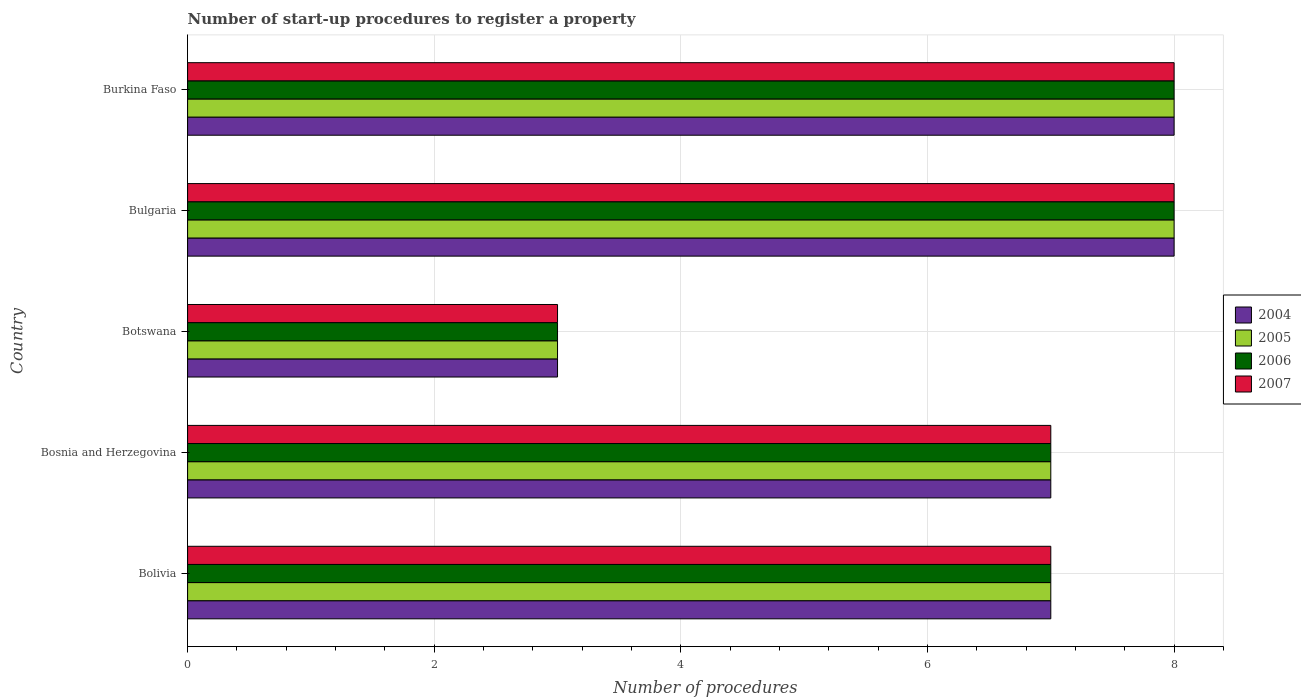How many different coloured bars are there?
Offer a very short reply. 4. How many groups of bars are there?
Keep it short and to the point. 5. Are the number of bars per tick equal to the number of legend labels?
Keep it short and to the point. Yes. Are the number of bars on each tick of the Y-axis equal?
Offer a very short reply. Yes. Across all countries, what is the maximum number of procedures required to register a property in 2007?
Keep it short and to the point. 8. Across all countries, what is the minimum number of procedures required to register a property in 2007?
Make the answer very short. 3. In which country was the number of procedures required to register a property in 2007 maximum?
Make the answer very short. Bulgaria. In which country was the number of procedures required to register a property in 2006 minimum?
Your response must be concise. Botswana. What is the total number of procedures required to register a property in 2007 in the graph?
Offer a very short reply. 33. Is the number of procedures required to register a property in 2006 in Bosnia and Herzegovina less than that in Bulgaria?
Provide a succinct answer. Yes. Is the difference between the number of procedures required to register a property in 2006 in Bolivia and Burkina Faso greater than the difference between the number of procedures required to register a property in 2007 in Bolivia and Burkina Faso?
Provide a succinct answer. No. What is the difference between the highest and the second highest number of procedures required to register a property in 2004?
Provide a short and direct response. 0. What is the difference between the highest and the lowest number of procedures required to register a property in 2005?
Provide a succinct answer. 5. In how many countries, is the number of procedures required to register a property in 2006 greater than the average number of procedures required to register a property in 2006 taken over all countries?
Your answer should be compact. 4. Is the sum of the number of procedures required to register a property in 2005 in Botswana and Bulgaria greater than the maximum number of procedures required to register a property in 2006 across all countries?
Ensure brevity in your answer.  Yes. What does the 3rd bar from the top in Botswana represents?
Give a very brief answer. 2005. How many bars are there?
Your response must be concise. 20. Are all the bars in the graph horizontal?
Offer a terse response. Yes. How many countries are there in the graph?
Provide a short and direct response. 5. What is the difference between two consecutive major ticks on the X-axis?
Make the answer very short. 2. Does the graph contain any zero values?
Keep it short and to the point. No. Does the graph contain grids?
Your answer should be compact. Yes. Where does the legend appear in the graph?
Your answer should be very brief. Center right. How are the legend labels stacked?
Give a very brief answer. Vertical. What is the title of the graph?
Make the answer very short. Number of start-up procedures to register a property. What is the label or title of the X-axis?
Make the answer very short. Number of procedures. What is the label or title of the Y-axis?
Your answer should be compact. Country. What is the Number of procedures of 2005 in Bolivia?
Keep it short and to the point. 7. What is the Number of procedures of 2006 in Bolivia?
Ensure brevity in your answer.  7. What is the Number of procedures in 2007 in Bolivia?
Give a very brief answer. 7. What is the Number of procedures in 2005 in Bosnia and Herzegovina?
Your answer should be compact. 7. What is the Number of procedures in 2004 in Botswana?
Ensure brevity in your answer.  3. What is the Number of procedures of 2006 in Botswana?
Offer a very short reply. 3. What is the Number of procedures of 2007 in Botswana?
Make the answer very short. 3. What is the Number of procedures of 2004 in Burkina Faso?
Your answer should be compact. 8. What is the Number of procedures in 2006 in Burkina Faso?
Offer a terse response. 8. What is the Number of procedures in 2007 in Burkina Faso?
Make the answer very short. 8. Across all countries, what is the maximum Number of procedures of 2004?
Give a very brief answer. 8. Across all countries, what is the maximum Number of procedures of 2005?
Make the answer very short. 8. Across all countries, what is the maximum Number of procedures in 2006?
Keep it short and to the point. 8. Across all countries, what is the maximum Number of procedures of 2007?
Provide a succinct answer. 8. Across all countries, what is the minimum Number of procedures of 2004?
Your answer should be very brief. 3. Across all countries, what is the minimum Number of procedures of 2006?
Provide a succinct answer. 3. Across all countries, what is the minimum Number of procedures of 2007?
Ensure brevity in your answer.  3. What is the total Number of procedures of 2004 in the graph?
Offer a very short reply. 33. What is the total Number of procedures of 2005 in the graph?
Your response must be concise. 33. What is the total Number of procedures of 2006 in the graph?
Your response must be concise. 33. What is the total Number of procedures of 2007 in the graph?
Provide a short and direct response. 33. What is the difference between the Number of procedures of 2005 in Bolivia and that in Bosnia and Herzegovina?
Offer a terse response. 0. What is the difference between the Number of procedures of 2006 in Bolivia and that in Bosnia and Herzegovina?
Provide a succinct answer. 0. What is the difference between the Number of procedures of 2007 in Bolivia and that in Bosnia and Herzegovina?
Keep it short and to the point. 0. What is the difference between the Number of procedures of 2004 in Bolivia and that in Botswana?
Your answer should be very brief. 4. What is the difference between the Number of procedures in 2005 in Bolivia and that in Botswana?
Make the answer very short. 4. What is the difference between the Number of procedures in 2006 in Bolivia and that in Botswana?
Offer a terse response. 4. What is the difference between the Number of procedures in 2007 in Bolivia and that in Botswana?
Your answer should be compact. 4. What is the difference between the Number of procedures in 2006 in Bolivia and that in Bulgaria?
Your answer should be compact. -1. What is the difference between the Number of procedures in 2006 in Bolivia and that in Burkina Faso?
Keep it short and to the point. -1. What is the difference between the Number of procedures of 2007 in Bolivia and that in Burkina Faso?
Ensure brevity in your answer.  -1. What is the difference between the Number of procedures of 2004 in Bosnia and Herzegovina and that in Botswana?
Provide a short and direct response. 4. What is the difference between the Number of procedures in 2005 in Bosnia and Herzegovina and that in Bulgaria?
Your answer should be compact. -1. What is the difference between the Number of procedures in 2004 in Bosnia and Herzegovina and that in Burkina Faso?
Your answer should be very brief. -1. What is the difference between the Number of procedures in 2006 in Bosnia and Herzegovina and that in Burkina Faso?
Your answer should be very brief. -1. What is the difference between the Number of procedures of 2007 in Bosnia and Herzegovina and that in Burkina Faso?
Offer a terse response. -1. What is the difference between the Number of procedures of 2005 in Botswana and that in Bulgaria?
Make the answer very short. -5. What is the difference between the Number of procedures in 2007 in Botswana and that in Bulgaria?
Your response must be concise. -5. What is the difference between the Number of procedures in 2004 in Botswana and that in Burkina Faso?
Provide a short and direct response. -5. What is the difference between the Number of procedures of 2005 in Botswana and that in Burkina Faso?
Your response must be concise. -5. What is the difference between the Number of procedures in 2004 in Bulgaria and that in Burkina Faso?
Keep it short and to the point. 0. What is the difference between the Number of procedures of 2004 in Bolivia and the Number of procedures of 2005 in Bosnia and Herzegovina?
Offer a very short reply. 0. What is the difference between the Number of procedures of 2004 in Bolivia and the Number of procedures of 2006 in Bosnia and Herzegovina?
Your answer should be compact. 0. What is the difference between the Number of procedures in 2004 in Bolivia and the Number of procedures in 2007 in Bosnia and Herzegovina?
Make the answer very short. 0. What is the difference between the Number of procedures of 2006 in Bolivia and the Number of procedures of 2007 in Bosnia and Herzegovina?
Provide a succinct answer. 0. What is the difference between the Number of procedures in 2004 in Bolivia and the Number of procedures in 2005 in Botswana?
Provide a succinct answer. 4. What is the difference between the Number of procedures of 2004 in Bolivia and the Number of procedures of 2006 in Botswana?
Your response must be concise. 4. What is the difference between the Number of procedures in 2004 in Bolivia and the Number of procedures in 2007 in Botswana?
Give a very brief answer. 4. What is the difference between the Number of procedures in 2005 in Bolivia and the Number of procedures in 2007 in Botswana?
Offer a terse response. 4. What is the difference between the Number of procedures in 2005 in Bolivia and the Number of procedures in 2007 in Bulgaria?
Your answer should be compact. -1. What is the difference between the Number of procedures in 2006 in Bolivia and the Number of procedures in 2007 in Bulgaria?
Keep it short and to the point. -1. What is the difference between the Number of procedures in 2004 in Bolivia and the Number of procedures in 2005 in Burkina Faso?
Ensure brevity in your answer.  -1. What is the difference between the Number of procedures of 2004 in Bolivia and the Number of procedures of 2006 in Burkina Faso?
Your answer should be very brief. -1. What is the difference between the Number of procedures of 2004 in Bosnia and Herzegovina and the Number of procedures of 2007 in Botswana?
Provide a short and direct response. 4. What is the difference between the Number of procedures in 2005 in Bosnia and Herzegovina and the Number of procedures in 2007 in Botswana?
Provide a short and direct response. 4. What is the difference between the Number of procedures in 2005 in Bosnia and Herzegovina and the Number of procedures in 2006 in Bulgaria?
Give a very brief answer. -1. What is the difference between the Number of procedures of 2005 in Bosnia and Herzegovina and the Number of procedures of 2007 in Bulgaria?
Your response must be concise. -1. What is the difference between the Number of procedures in 2006 in Bosnia and Herzegovina and the Number of procedures in 2007 in Bulgaria?
Your answer should be compact. -1. What is the difference between the Number of procedures in 2004 in Bosnia and Herzegovina and the Number of procedures in 2007 in Burkina Faso?
Provide a succinct answer. -1. What is the difference between the Number of procedures in 2005 in Bosnia and Herzegovina and the Number of procedures in 2007 in Burkina Faso?
Ensure brevity in your answer.  -1. What is the difference between the Number of procedures in 2006 in Bosnia and Herzegovina and the Number of procedures in 2007 in Burkina Faso?
Offer a very short reply. -1. What is the difference between the Number of procedures of 2004 in Botswana and the Number of procedures of 2007 in Bulgaria?
Offer a terse response. -5. What is the difference between the Number of procedures of 2005 in Botswana and the Number of procedures of 2006 in Bulgaria?
Offer a terse response. -5. What is the difference between the Number of procedures of 2004 in Botswana and the Number of procedures of 2005 in Burkina Faso?
Your answer should be compact. -5. What is the difference between the Number of procedures of 2004 in Botswana and the Number of procedures of 2006 in Burkina Faso?
Give a very brief answer. -5. What is the difference between the Number of procedures of 2005 in Botswana and the Number of procedures of 2007 in Burkina Faso?
Offer a terse response. -5. What is the difference between the Number of procedures in 2004 in Bulgaria and the Number of procedures in 2007 in Burkina Faso?
Your answer should be compact. 0. What is the difference between the Number of procedures in 2006 in Bulgaria and the Number of procedures in 2007 in Burkina Faso?
Keep it short and to the point. 0. What is the average Number of procedures in 2006 per country?
Your answer should be very brief. 6.6. What is the difference between the Number of procedures of 2004 and Number of procedures of 2007 in Bolivia?
Give a very brief answer. 0. What is the difference between the Number of procedures in 2004 and Number of procedures in 2006 in Bosnia and Herzegovina?
Ensure brevity in your answer.  0. What is the difference between the Number of procedures of 2004 and Number of procedures of 2007 in Bosnia and Herzegovina?
Provide a succinct answer. 0. What is the difference between the Number of procedures in 2006 and Number of procedures in 2007 in Bosnia and Herzegovina?
Keep it short and to the point. 0. What is the difference between the Number of procedures in 2004 and Number of procedures in 2005 in Botswana?
Make the answer very short. 0. What is the difference between the Number of procedures in 2004 and Number of procedures in 2006 in Botswana?
Your answer should be very brief. 0. What is the difference between the Number of procedures of 2004 and Number of procedures of 2007 in Botswana?
Give a very brief answer. 0. What is the difference between the Number of procedures in 2005 and Number of procedures in 2007 in Botswana?
Offer a very short reply. 0. What is the difference between the Number of procedures in 2004 and Number of procedures in 2005 in Bulgaria?
Offer a very short reply. 0. What is the difference between the Number of procedures of 2005 and Number of procedures of 2006 in Bulgaria?
Your answer should be compact. 0. What is the difference between the Number of procedures of 2004 and Number of procedures of 2007 in Burkina Faso?
Provide a succinct answer. 0. What is the ratio of the Number of procedures of 2004 in Bolivia to that in Bosnia and Herzegovina?
Make the answer very short. 1. What is the ratio of the Number of procedures of 2005 in Bolivia to that in Bosnia and Herzegovina?
Make the answer very short. 1. What is the ratio of the Number of procedures in 2004 in Bolivia to that in Botswana?
Ensure brevity in your answer.  2.33. What is the ratio of the Number of procedures in 2005 in Bolivia to that in Botswana?
Offer a very short reply. 2.33. What is the ratio of the Number of procedures of 2006 in Bolivia to that in Botswana?
Your answer should be very brief. 2.33. What is the ratio of the Number of procedures in 2007 in Bolivia to that in Botswana?
Make the answer very short. 2.33. What is the ratio of the Number of procedures in 2004 in Bolivia to that in Bulgaria?
Provide a succinct answer. 0.88. What is the ratio of the Number of procedures in 2005 in Bolivia to that in Bulgaria?
Offer a very short reply. 0.88. What is the ratio of the Number of procedures in 2007 in Bolivia to that in Bulgaria?
Make the answer very short. 0.88. What is the ratio of the Number of procedures in 2006 in Bolivia to that in Burkina Faso?
Ensure brevity in your answer.  0.88. What is the ratio of the Number of procedures of 2004 in Bosnia and Herzegovina to that in Botswana?
Keep it short and to the point. 2.33. What is the ratio of the Number of procedures in 2005 in Bosnia and Herzegovina to that in Botswana?
Your response must be concise. 2.33. What is the ratio of the Number of procedures in 2006 in Bosnia and Herzegovina to that in Botswana?
Make the answer very short. 2.33. What is the ratio of the Number of procedures of 2007 in Bosnia and Herzegovina to that in Botswana?
Provide a succinct answer. 2.33. What is the ratio of the Number of procedures of 2004 in Bosnia and Herzegovina to that in Burkina Faso?
Your answer should be compact. 0.88. What is the ratio of the Number of procedures in 2005 in Bosnia and Herzegovina to that in Burkina Faso?
Give a very brief answer. 0.88. What is the ratio of the Number of procedures of 2007 in Bosnia and Herzegovina to that in Burkina Faso?
Your answer should be very brief. 0.88. What is the ratio of the Number of procedures of 2004 in Botswana to that in Bulgaria?
Provide a short and direct response. 0.38. What is the ratio of the Number of procedures of 2004 in Botswana to that in Burkina Faso?
Your response must be concise. 0.38. What is the ratio of the Number of procedures in 2006 in Botswana to that in Burkina Faso?
Offer a terse response. 0.38. What is the ratio of the Number of procedures of 2005 in Bulgaria to that in Burkina Faso?
Your answer should be very brief. 1. What is the ratio of the Number of procedures in 2006 in Bulgaria to that in Burkina Faso?
Your response must be concise. 1. What is the difference between the highest and the second highest Number of procedures of 2007?
Ensure brevity in your answer.  0. What is the difference between the highest and the lowest Number of procedures of 2004?
Your answer should be compact. 5. What is the difference between the highest and the lowest Number of procedures of 2005?
Your response must be concise. 5. 